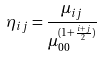Convert formula to latex. <formula><loc_0><loc_0><loc_500><loc_500>\eta _ { i j } = \frac { \mu _ { i j } } { \mu _ { 0 0 } ^ { ( 1 + \frac { i + j } { 2 } ) } }</formula> 